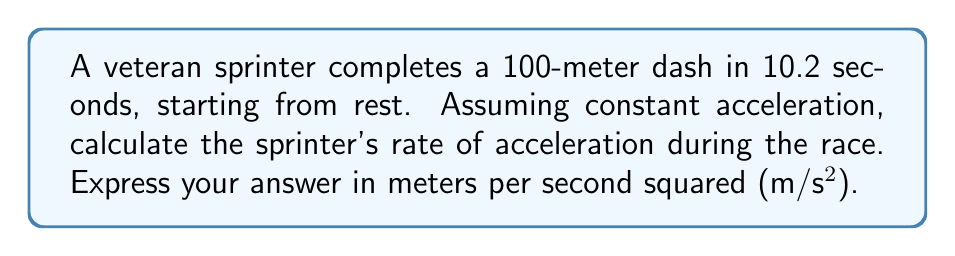Could you help me with this problem? To solve this problem, we'll use the kinematic equation that relates displacement, time, initial velocity, and acceleration:

$$s = ut + \frac{1}{2}at^2$$

Where:
$s$ = displacement (100 meters)
$u$ = initial velocity (0 m/s, starting from rest)
$t$ = time (10.2 seconds)
$a$ = acceleration (what we're solving for)

Steps:
1) Substitute the known values into the equation:
   $$100 = 0 \cdot 10.2 + \frac{1}{2}a(10.2)^2$$

2) Simplify:
   $$100 = \frac{1}{2}a(104.04)$$

3) Multiply both sides by 2:
   $$200 = a(104.04)$$

4) Divide both sides by 104.04:
   $$\frac{200}{104.04} = a$$

5) Calculate:
   $$a \approx 1.92 \text{ m/s²}$$

This acceleration rate is consistent with elite sprinters, who typically achieve average accelerations between 1.5 and 2.5 m/s² over a 100-meter dash.
Answer: $1.92 \text{ m/s²}$ 